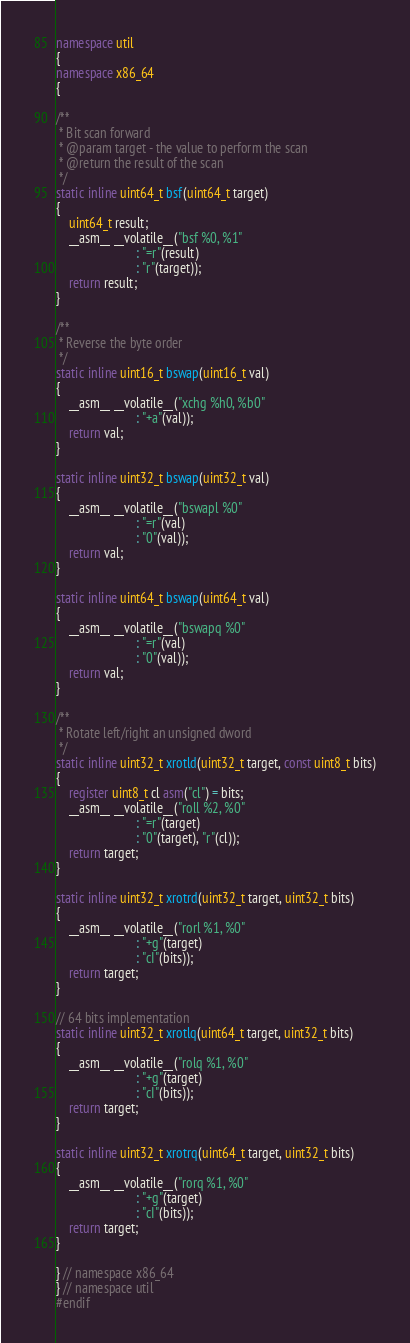<code> <loc_0><loc_0><loc_500><loc_500><_C++_>namespace util
{
namespace x86_64
{

/**
 * Bit scan forward
 * @param target - the value to perform the scan
 * @return the result of the scan
 */
static inline uint64_t bsf(uint64_t target)
{
    uint64_t result;
    __asm__ __volatile__("bsf %0, %1"
                         : "=r"(result)
                         : "r"(target));
    return result;
}

/**
 * Reverse the byte order
 */
static inline uint16_t bswap(uint16_t val)
{
    __asm__ __volatile__("xchg %h0, %b0"
                         : "+a"(val));
    return val;
}

static inline uint32_t bswap(uint32_t val)
{
    __asm__ __volatile__("bswapl %0"
                         : "=r"(val)
                         : "0"(val));
    return val;
}

static inline uint64_t bswap(uint64_t val)
{
    __asm__ __volatile__("bswapq %0"
                         : "=r"(val)
                         : "0"(val));
    return val;
}

/**
 * Rotate left/right an unsigned dword
 */
static inline uint32_t xrotld(uint32_t target, const uint8_t bits)
{
    register uint8_t cl asm("cl") = bits;
    __asm__ __volatile__("roll %2, %0"
                         : "=r"(target)
                         : "0"(target), "r"(cl));
    return target;
}

static inline uint32_t xrotrd(uint32_t target, uint32_t bits)
{
    __asm__ __volatile__("rorl %1, %0"
                         : "+g"(target)
                         : "cI"(bits));
    return target;
}

// 64 bits implementation
static inline uint32_t xrotlq(uint64_t target, uint32_t bits)
{
    __asm__ __volatile__("rolq %1, %0"
                         : "+g"(target)
                         : "cI"(bits));
    return target;
}

static inline uint32_t xrotrq(uint64_t target, uint32_t bits)
{
    __asm__ __volatile__("rorq %1, %0"
                         : "+g"(target)
                         : "cI"(bits));
    return target;
}

} // namespace x86_64
} // namespace util
#endif
</code> 